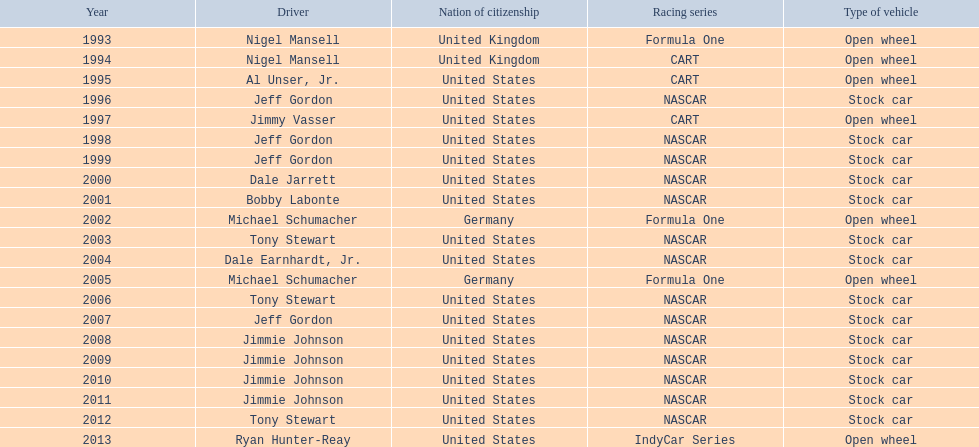How many times did jeff gordon win the award? 4. 